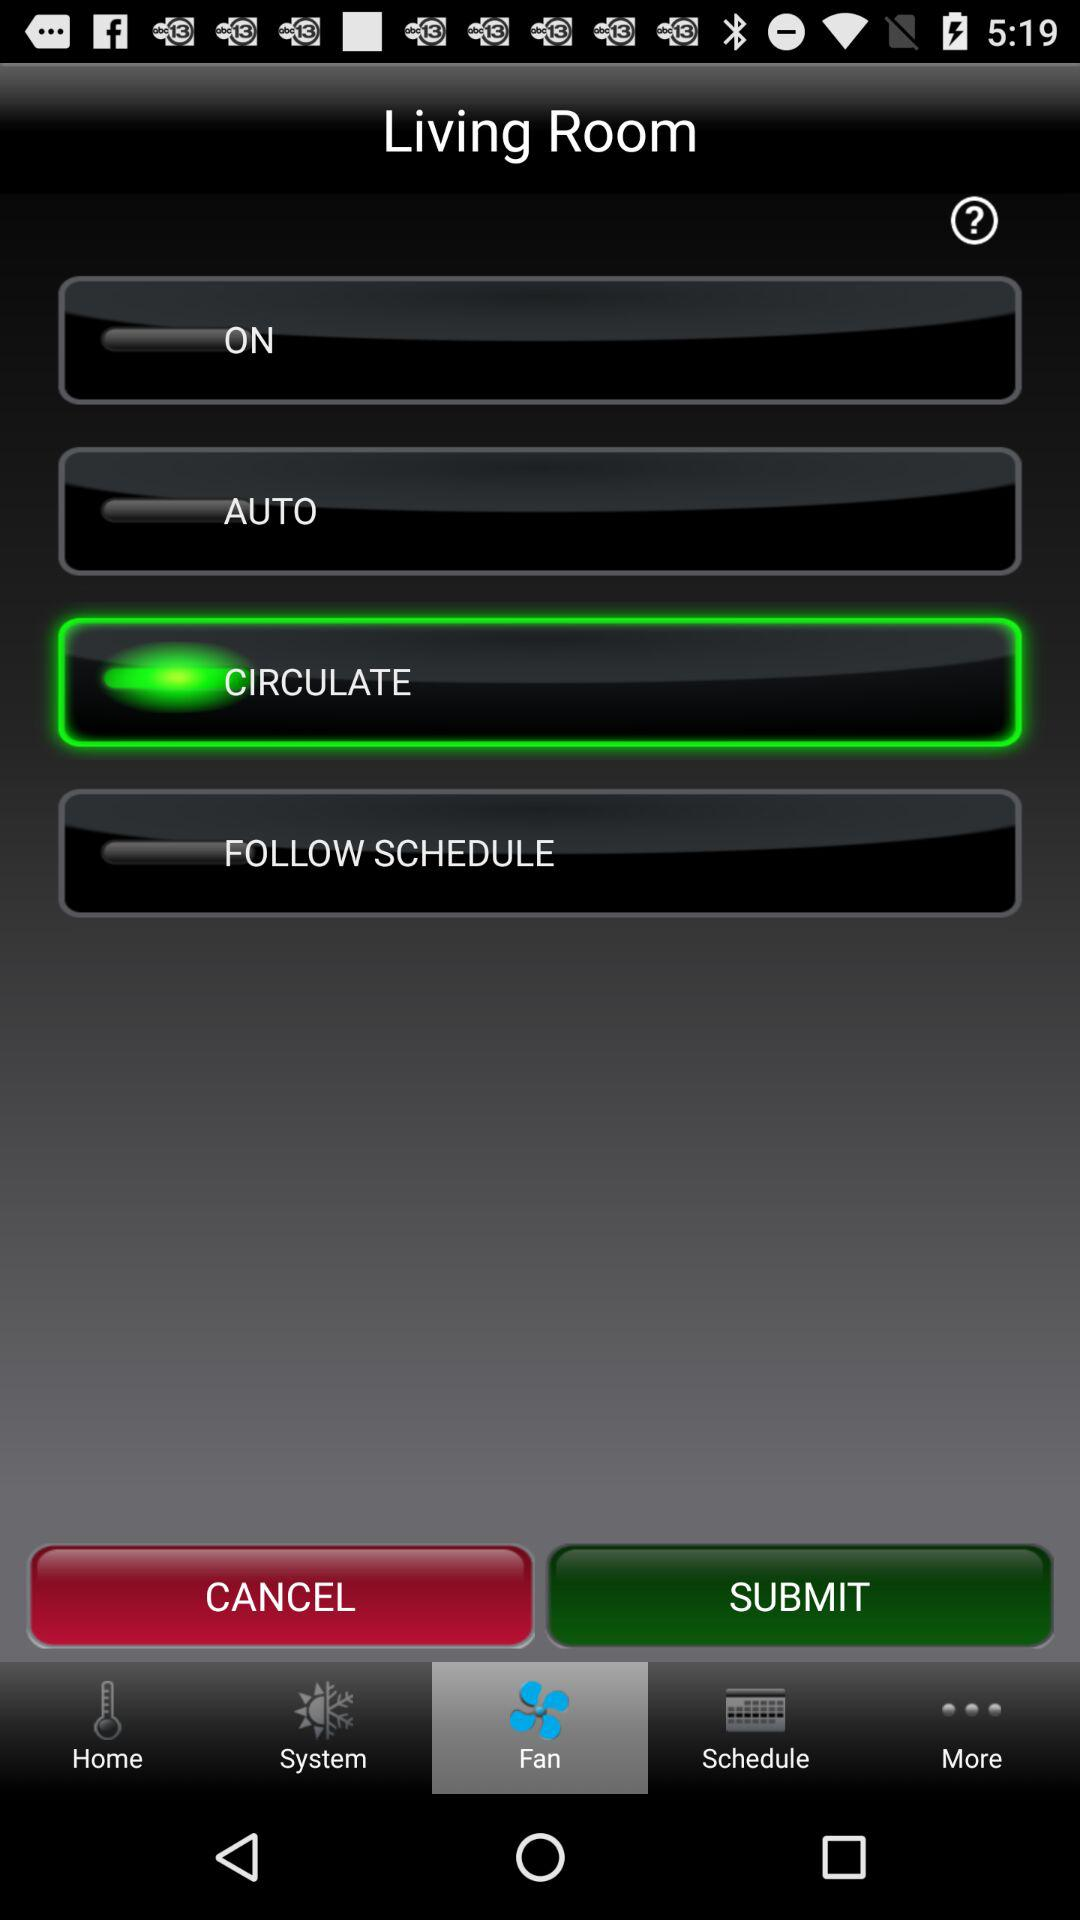What option am I on? The option is "Fan". 